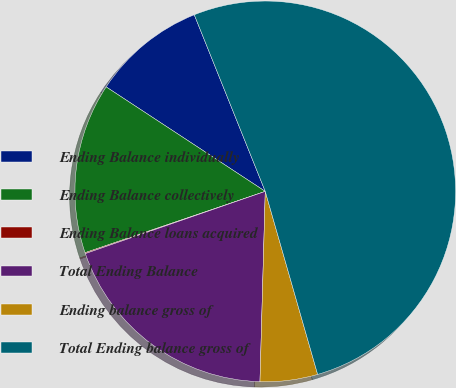<chart> <loc_0><loc_0><loc_500><loc_500><pie_chart><fcel>Ending Balance individually<fcel>Ending Balance collectively<fcel>Ending Balance loans acquired<fcel>Total Ending Balance<fcel>Ending balance gross of<fcel>Total Ending balance gross of<nl><fcel>9.67%<fcel>14.47%<fcel>0.08%<fcel>19.26%<fcel>4.88%<fcel>51.65%<nl></chart> 